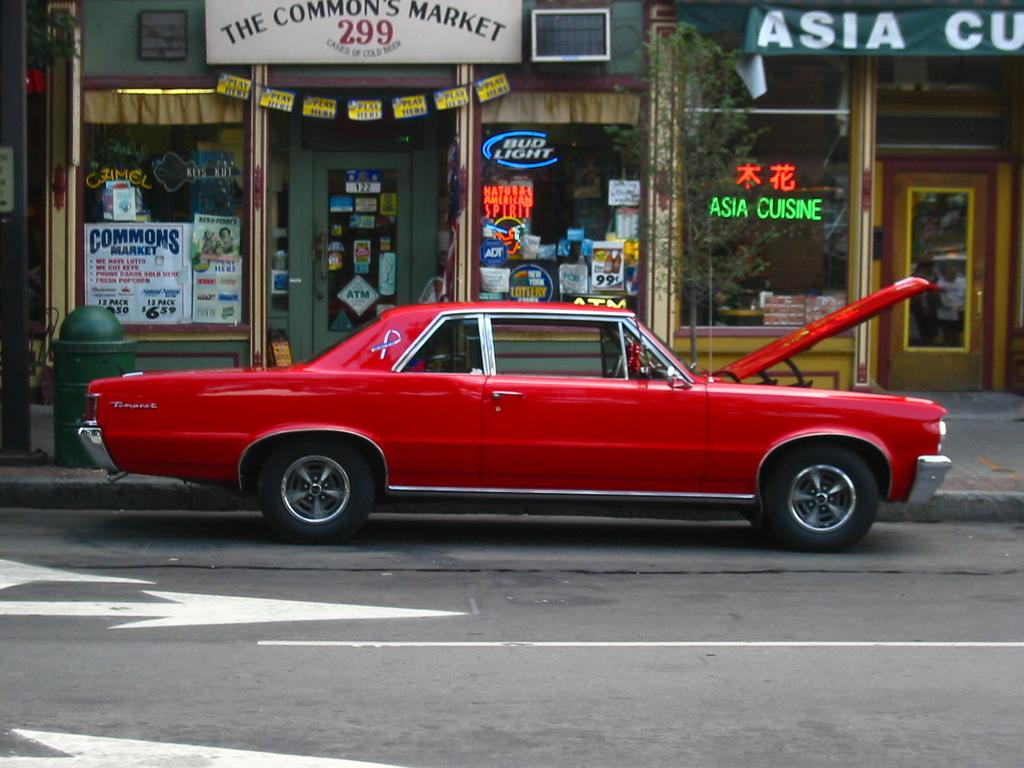Provide a one-sentence caption for the provided image. A parked red car with its hood up in front of an Asian restuarant. 